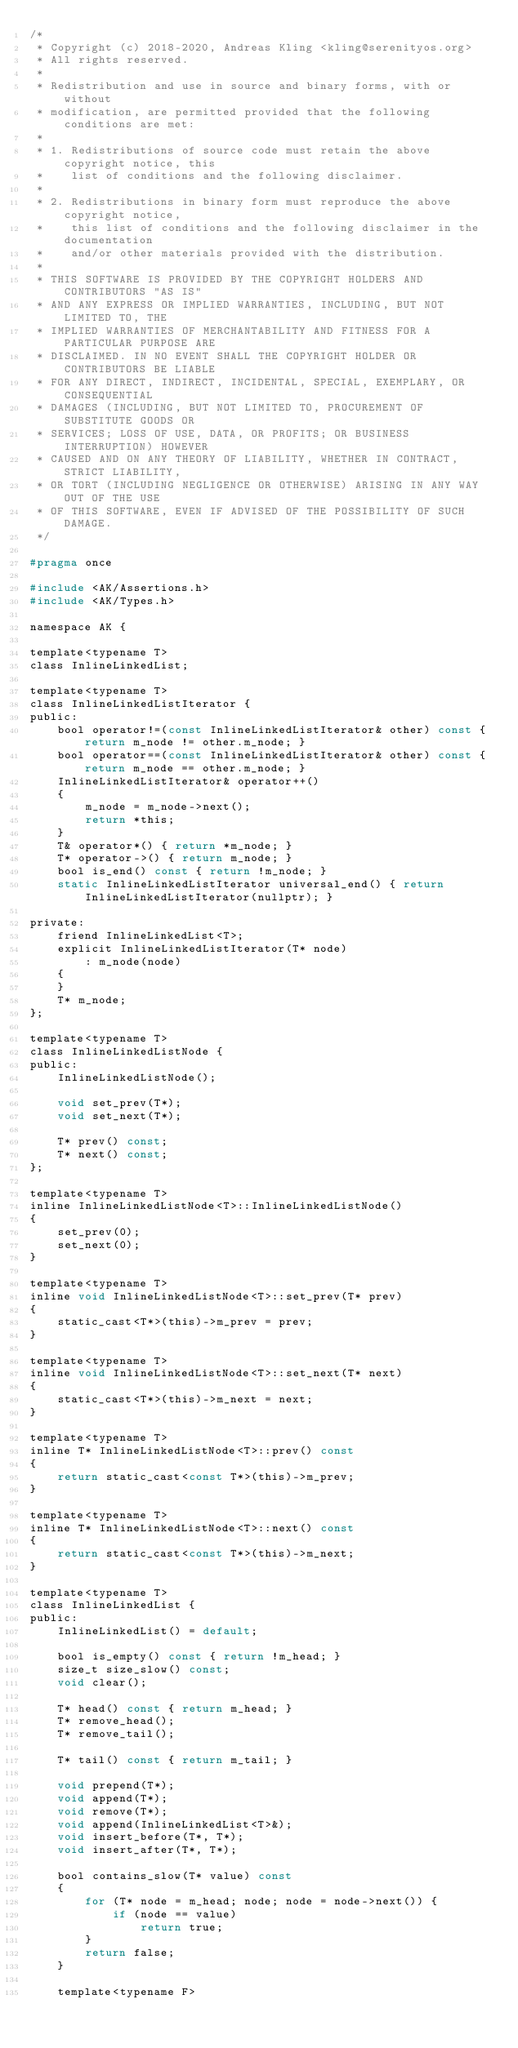<code> <loc_0><loc_0><loc_500><loc_500><_C_>/*
 * Copyright (c) 2018-2020, Andreas Kling <kling@serenityos.org>
 * All rights reserved.
 *
 * Redistribution and use in source and binary forms, with or without
 * modification, are permitted provided that the following conditions are met:
 *
 * 1. Redistributions of source code must retain the above copyright notice, this
 *    list of conditions and the following disclaimer.
 *
 * 2. Redistributions in binary form must reproduce the above copyright notice,
 *    this list of conditions and the following disclaimer in the documentation
 *    and/or other materials provided with the distribution.
 *
 * THIS SOFTWARE IS PROVIDED BY THE COPYRIGHT HOLDERS AND CONTRIBUTORS "AS IS"
 * AND ANY EXPRESS OR IMPLIED WARRANTIES, INCLUDING, BUT NOT LIMITED TO, THE
 * IMPLIED WARRANTIES OF MERCHANTABILITY AND FITNESS FOR A PARTICULAR PURPOSE ARE
 * DISCLAIMED. IN NO EVENT SHALL THE COPYRIGHT HOLDER OR CONTRIBUTORS BE LIABLE
 * FOR ANY DIRECT, INDIRECT, INCIDENTAL, SPECIAL, EXEMPLARY, OR CONSEQUENTIAL
 * DAMAGES (INCLUDING, BUT NOT LIMITED TO, PROCUREMENT OF SUBSTITUTE GOODS OR
 * SERVICES; LOSS OF USE, DATA, OR PROFITS; OR BUSINESS INTERRUPTION) HOWEVER
 * CAUSED AND ON ANY THEORY OF LIABILITY, WHETHER IN CONTRACT, STRICT LIABILITY,
 * OR TORT (INCLUDING NEGLIGENCE OR OTHERWISE) ARISING IN ANY WAY OUT OF THE USE
 * OF THIS SOFTWARE, EVEN IF ADVISED OF THE POSSIBILITY OF SUCH DAMAGE.
 */

#pragma once

#include <AK/Assertions.h>
#include <AK/Types.h>

namespace AK {

template<typename T>
class InlineLinkedList;

template<typename T>
class InlineLinkedListIterator {
public:
    bool operator!=(const InlineLinkedListIterator& other) const { return m_node != other.m_node; }
    bool operator==(const InlineLinkedListIterator& other) const { return m_node == other.m_node; }
    InlineLinkedListIterator& operator++()
    {
        m_node = m_node->next();
        return *this;
    }
    T& operator*() { return *m_node; }
    T* operator->() { return m_node; }
    bool is_end() const { return !m_node; }
    static InlineLinkedListIterator universal_end() { return InlineLinkedListIterator(nullptr); }

private:
    friend InlineLinkedList<T>;
    explicit InlineLinkedListIterator(T* node)
        : m_node(node)
    {
    }
    T* m_node;
};

template<typename T>
class InlineLinkedListNode {
public:
    InlineLinkedListNode();

    void set_prev(T*);
    void set_next(T*);

    T* prev() const;
    T* next() const;
};

template<typename T>
inline InlineLinkedListNode<T>::InlineLinkedListNode()
{
    set_prev(0);
    set_next(0);
}

template<typename T>
inline void InlineLinkedListNode<T>::set_prev(T* prev)
{
    static_cast<T*>(this)->m_prev = prev;
}

template<typename T>
inline void InlineLinkedListNode<T>::set_next(T* next)
{
    static_cast<T*>(this)->m_next = next;
}

template<typename T>
inline T* InlineLinkedListNode<T>::prev() const
{
    return static_cast<const T*>(this)->m_prev;
}

template<typename T>
inline T* InlineLinkedListNode<T>::next() const
{
    return static_cast<const T*>(this)->m_next;
}

template<typename T>
class InlineLinkedList {
public:
    InlineLinkedList() = default;

    bool is_empty() const { return !m_head; }
    size_t size_slow() const;
    void clear();

    T* head() const { return m_head; }
    T* remove_head();
    T* remove_tail();

    T* tail() const { return m_tail; }

    void prepend(T*);
    void append(T*);
    void remove(T*);
    void append(InlineLinkedList<T>&);
    void insert_before(T*, T*);
    void insert_after(T*, T*);

    bool contains_slow(T* value) const
    {
        for (T* node = m_head; node; node = node->next()) {
            if (node == value)
                return true;
        }
        return false;
    }

    template<typename F></code> 